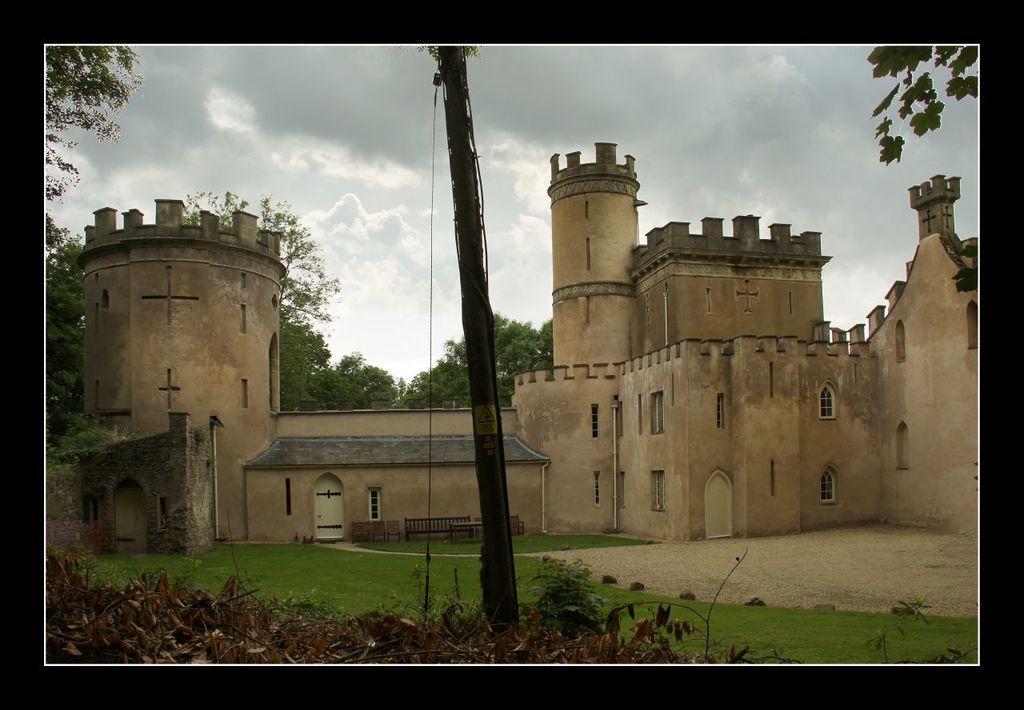Could you give a brief overview of what you see in this image? In the middle of the picture, we see an electric pole. Behind that, we see benches and a castle. At the bottom of the picture, we see grass, dried leaves and twigs. There are trees in the background. At the top of the picture, we see the sky. This picture might be a photo frame. 